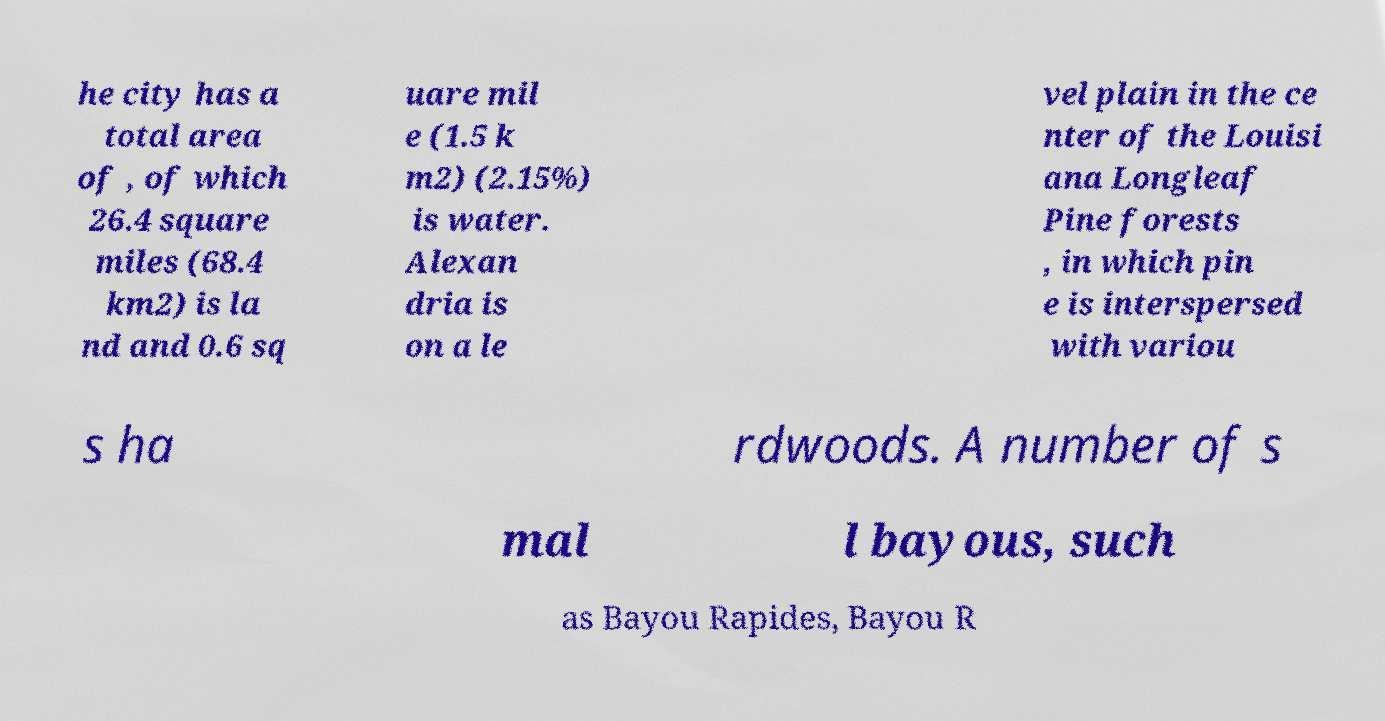There's text embedded in this image that I need extracted. Can you transcribe it verbatim? he city has a total area of , of which 26.4 square miles (68.4 km2) is la nd and 0.6 sq uare mil e (1.5 k m2) (2.15%) is water. Alexan dria is on a le vel plain in the ce nter of the Louisi ana Longleaf Pine forests , in which pin e is interspersed with variou s ha rdwoods. A number of s mal l bayous, such as Bayou Rapides, Bayou R 